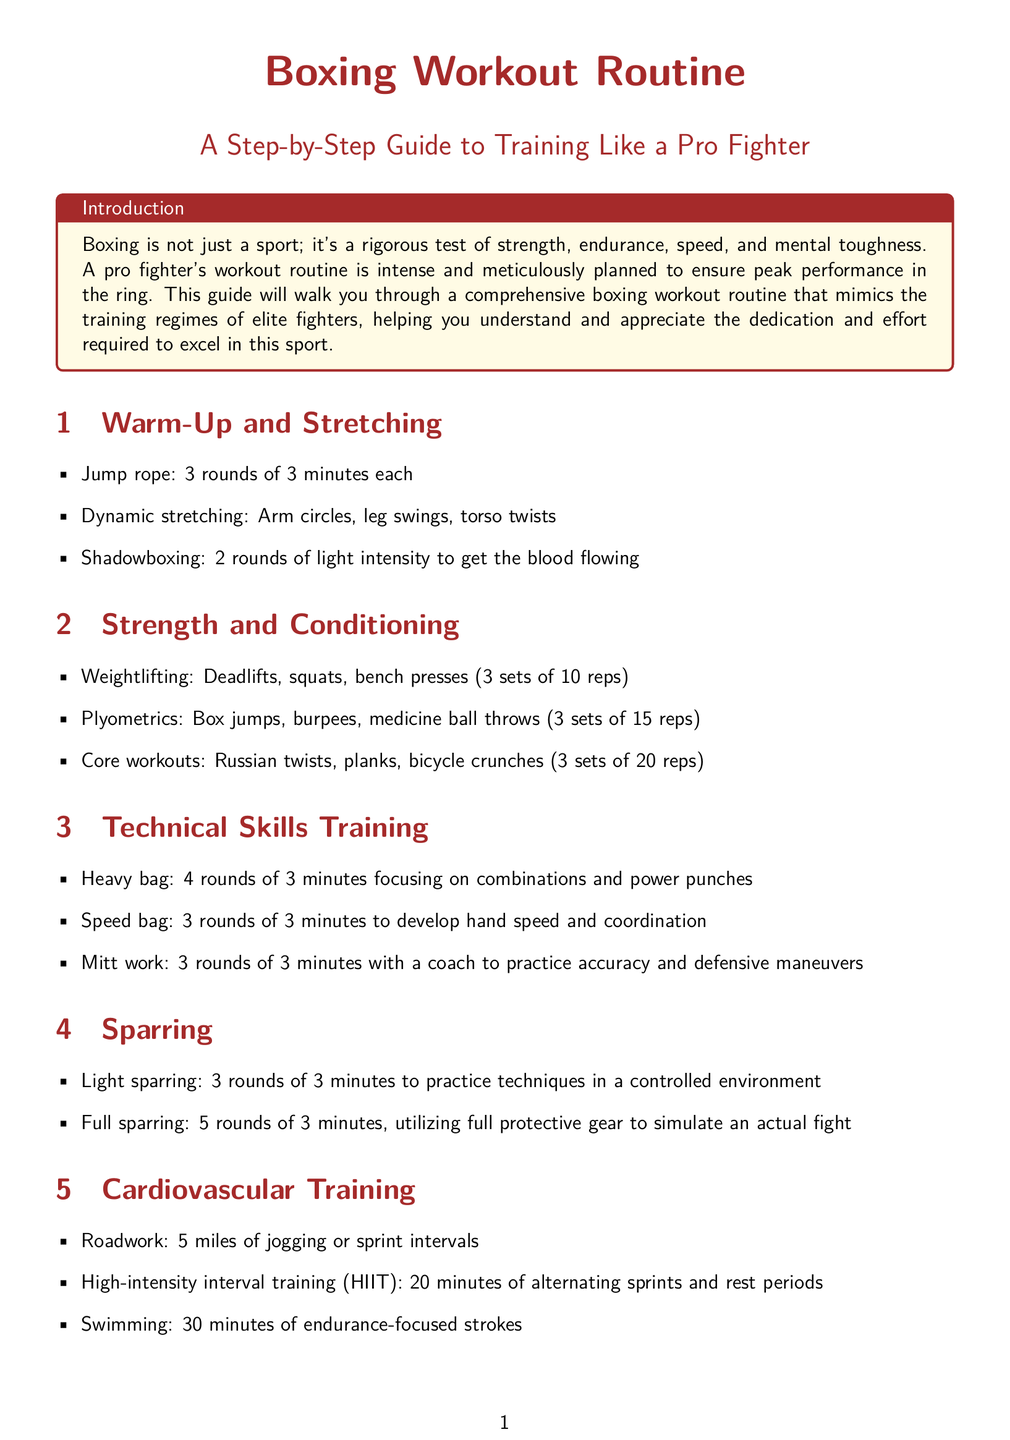What is the first exercise in the warm-up section? The first exercise listed is jump rope in the warm-up section.
Answer: Jump rope How many rounds of heavy bag training are required? The document states 4 rounds of heavy bag training are needed.
Answer: 4 rounds What is the recommended duration of the HIIT session? The HIIT session should last for 20 minutes according to the document.
Answer: 20 minutes How many minutes of static stretching are advised in the cool down? The cool down suggests 10 minutes of static stretching.
Answer: 10 minutes What type of training involves practicing techniques in a controlled environment? Light sparring is the term used for this training type in the document.
Answer: Light sparring What is the main focus of the core workouts mentioned? The core workouts primarily focus on exercises that strengthen the core muscles.
Answer: Core strength What do ice baths or contrast showers help with? They help reduce inflammation and speed up muscle recovery as mentioned.
Answer: Recovery How many sets of plyometrics are recommended? The document recommends 3 sets of plyometrics.
Answer: 3 sets 